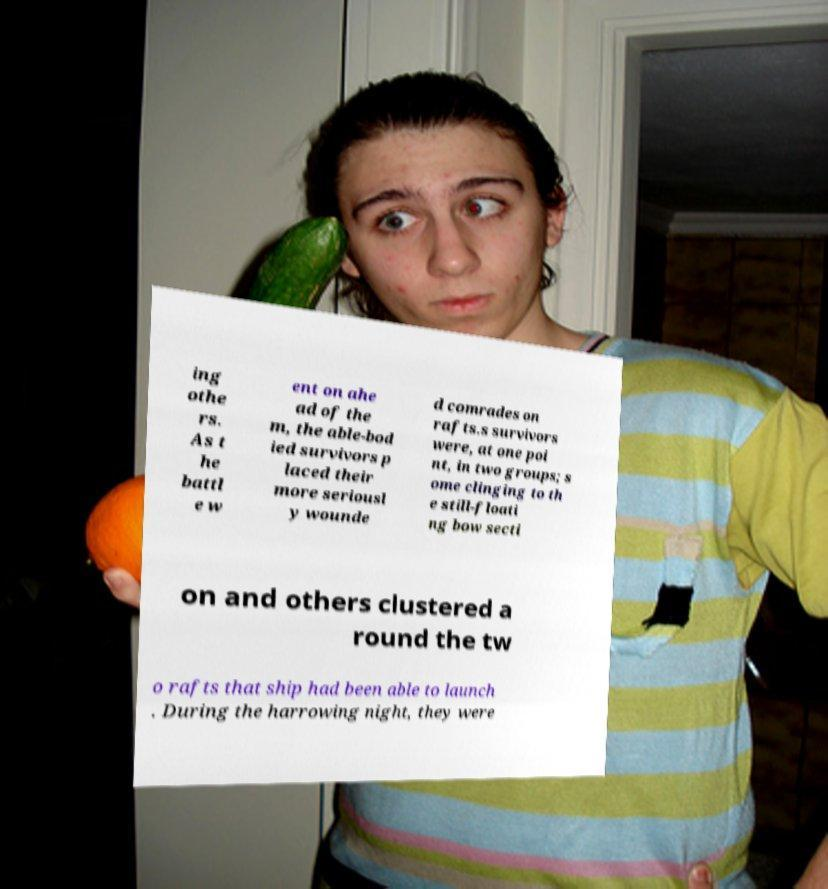What messages or text are displayed in this image? I need them in a readable, typed format. ing othe rs. As t he battl e w ent on ahe ad of the m, the able-bod ied survivors p laced their more seriousl y wounde d comrades on rafts.s survivors were, at one poi nt, in two groups; s ome clinging to th e still-floati ng bow secti on and others clustered a round the tw o rafts that ship had been able to launch . During the harrowing night, they were 